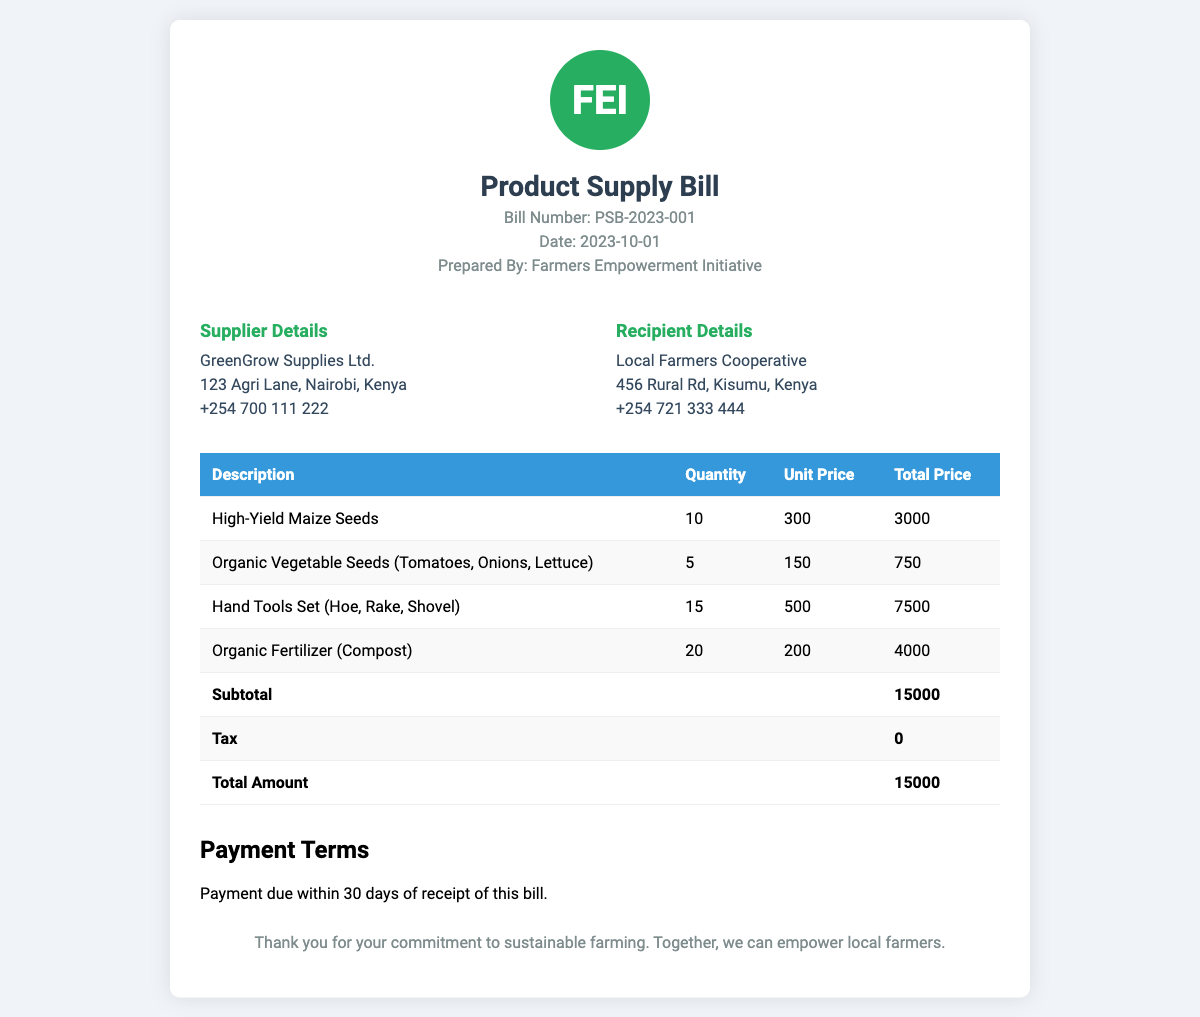What is the bill number? The bill number is listed in the document, specifically labeled as "Bill Number".
Answer: PSB-2023-001 Who prepared the bill? The document indicates who prepared the bill in the section labeled "Prepared By".
Answer: Farmers Empowerment Initiative What is the date of the bill? The date is stated prominently in the document under "Date".
Answer: 2023-10-01 What is the total amount of the bill? The total amount is found in the final line of the table where the total is calculated.
Answer: 15000 How many High-Yield Maize Seeds were procured? The quantity of High-Yield Maize Seeds is specified in the table under "Quantity".
Answer: 10 What is the subtotal before tax? The subtotal can be found in the table before any taxes are added.
Answer: 15000 Where is the supplier located? The supplier's address is provided in the "Supplier Details" section of the document.
Answer: 123 Agri Lane, Nairobi, Kenya What type of payment terms are described? The payment terms are mentioned towards the end of the document, indicating when payment is due.
Answer: Payment due within 30 days of receipt of this bill What is listed as part of the hand tools set? The hand tools included in the set are stated in the table under "Description".
Answer: Hoe, Rake, Shovel 